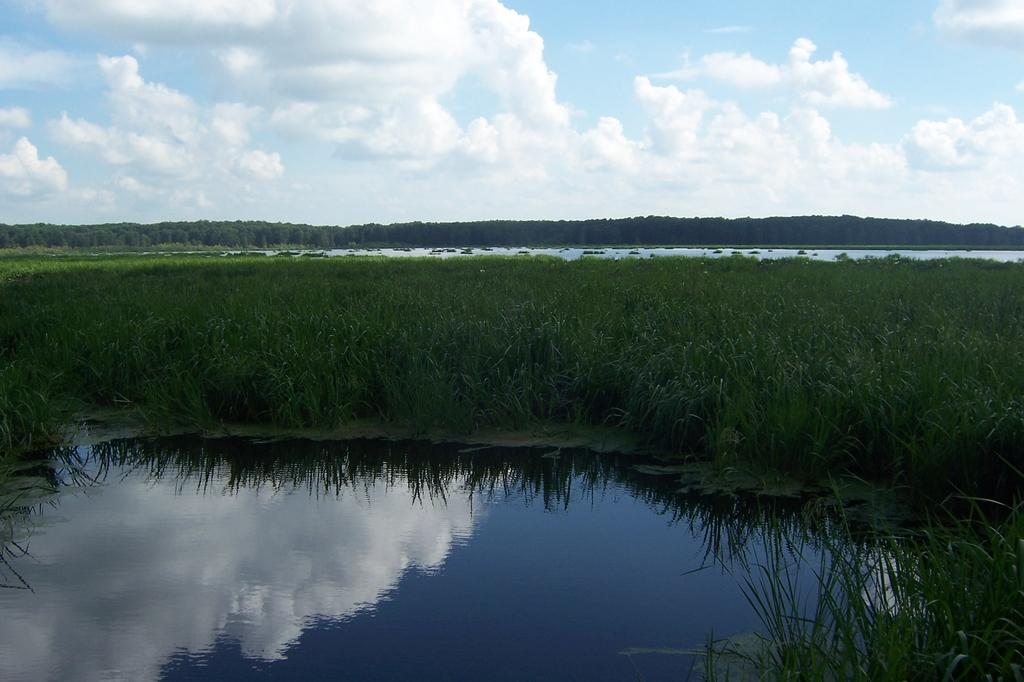What is one of the natural elements present in the image? There is water in the picture. What type of vegetation can be seen in the image? There is green grass in the picture. What can be seen in the background of the image? There are trees in the background of the picture. What is visible in the sky in the picture? There are clouds in the sky in the picture. What type of payment is being made in the image? There is no payment being made in the image; it features natural elements such as water, green grass, trees, and clouds. 